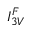Convert formula to latex. <formula><loc_0><loc_0><loc_500><loc_500>I _ { 3 V } ^ { F }</formula> 